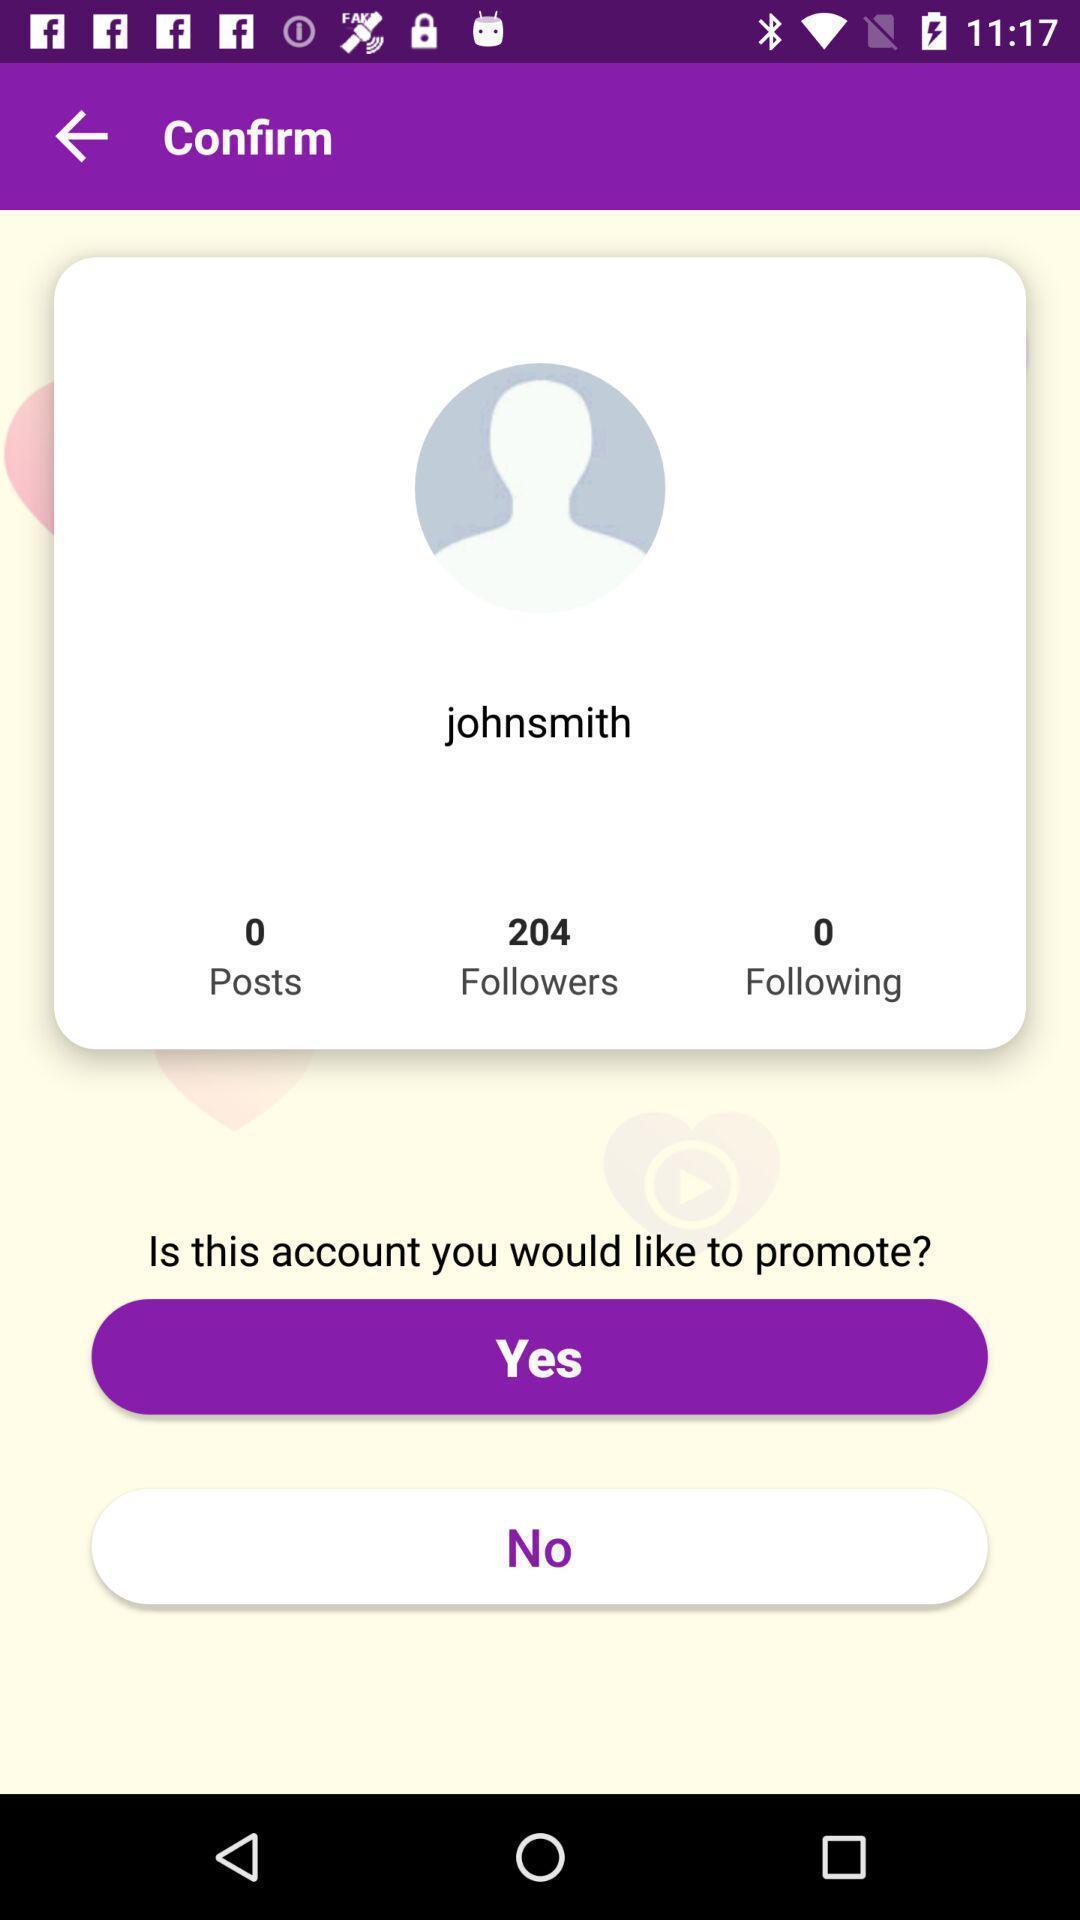Summarize the main components in this picture. Page showing the profile to promote. 